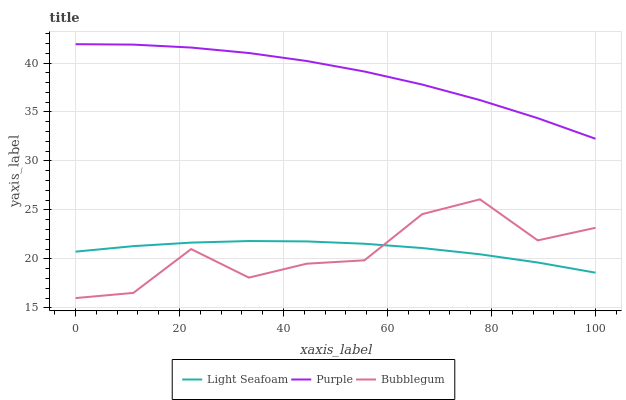Does Bubblegum have the minimum area under the curve?
Answer yes or no. Yes. Does Purple have the maximum area under the curve?
Answer yes or no. Yes. Does Light Seafoam have the minimum area under the curve?
Answer yes or no. No. Does Light Seafoam have the maximum area under the curve?
Answer yes or no. No. Is Light Seafoam the smoothest?
Answer yes or no. Yes. Is Bubblegum the roughest?
Answer yes or no. Yes. Is Bubblegum the smoothest?
Answer yes or no. No. Is Light Seafoam the roughest?
Answer yes or no. No. Does Bubblegum have the lowest value?
Answer yes or no. Yes. Does Light Seafoam have the lowest value?
Answer yes or no. No. Does Purple have the highest value?
Answer yes or no. Yes. Does Bubblegum have the highest value?
Answer yes or no. No. Is Bubblegum less than Purple?
Answer yes or no. Yes. Is Purple greater than Light Seafoam?
Answer yes or no. Yes. Does Light Seafoam intersect Bubblegum?
Answer yes or no. Yes. Is Light Seafoam less than Bubblegum?
Answer yes or no. No. Is Light Seafoam greater than Bubblegum?
Answer yes or no. No. Does Bubblegum intersect Purple?
Answer yes or no. No. 